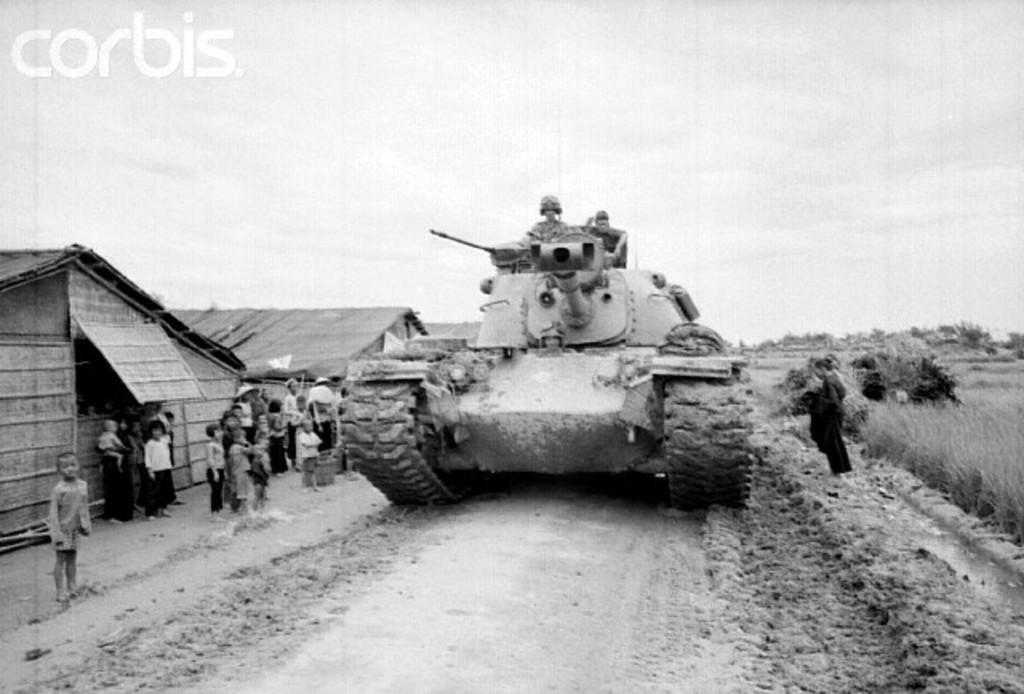What is the color scheme of the image? The image is black and white. What can be seen in the image besides the color scheme? There is a vehicle, people standing on the left side, houses, and some text in the top left corner of the image. How many minutes does it take for the smoke to come out of the can in the image? There is no smoke or can present in the image, so it is not possible to answer that question. 